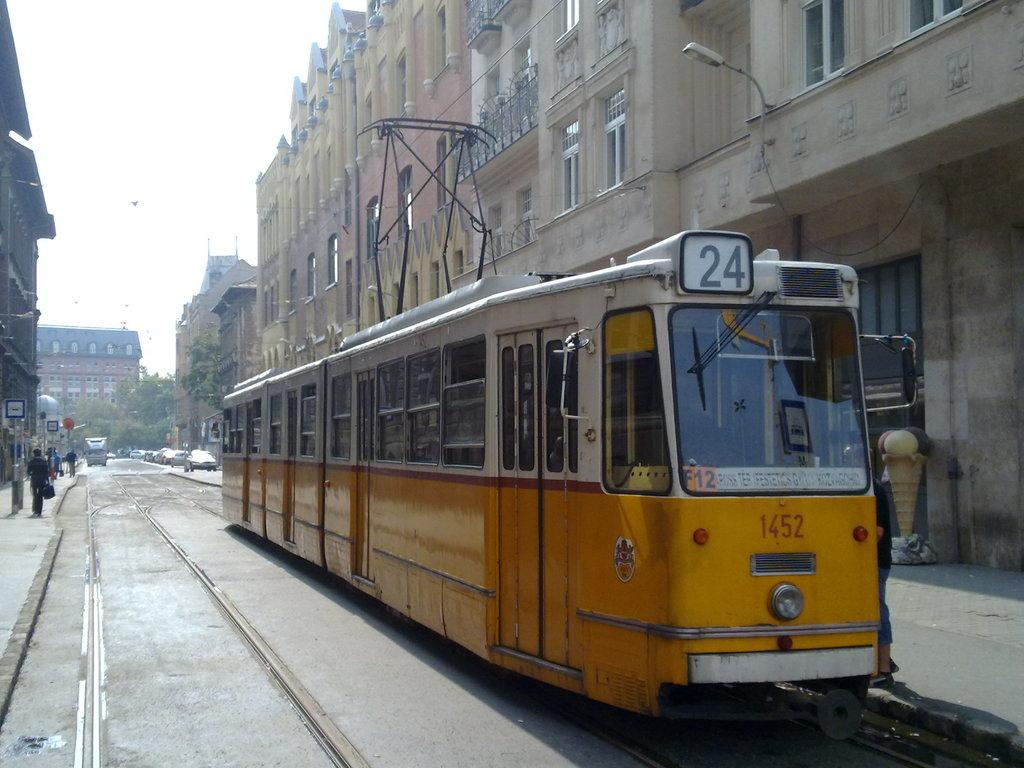<image>
Relay a brief, clear account of the picture shown. A yellow and white train that says 24 is going down a track between two buildings. 